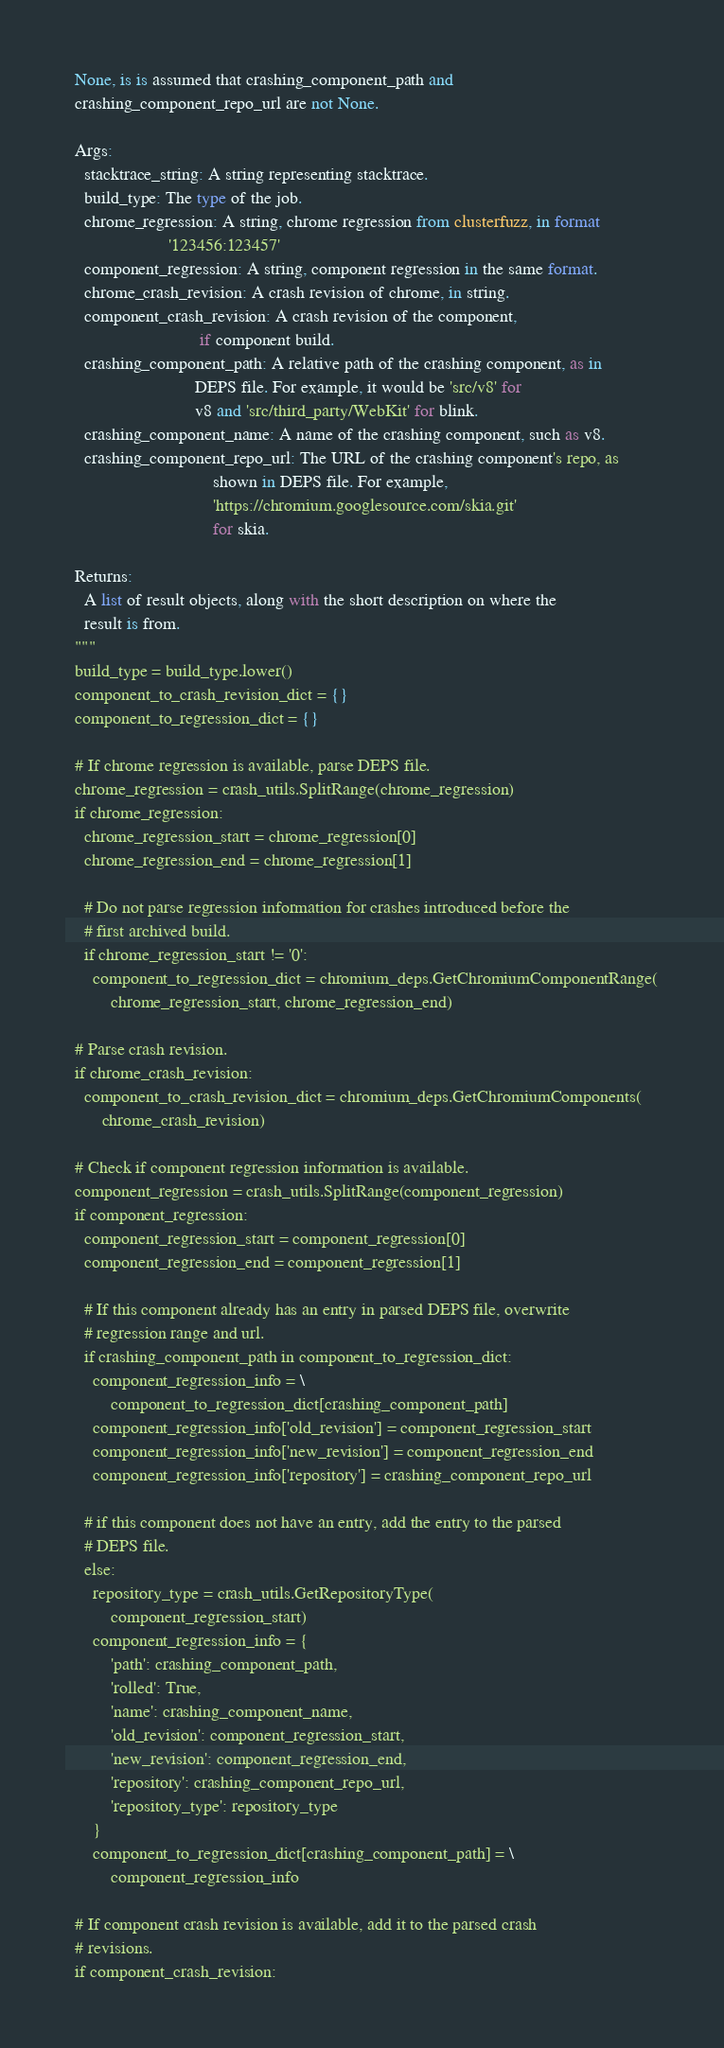<code> <loc_0><loc_0><loc_500><loc_500><_Python_>  None, is is assumed that crashing_component_path and
  crashing_component_repo_url are not None.

  Args:
    stacktrace_string: A string representing stacktrace.
    build_type: The type of the job.
    chrome_regression: A string, chrome regression from clusterfuzz, in format
                       '123456:123457'
    component_regression: A string, component regression in the same format.
    chrome_crash_revision: A crash revision of chrome, in string.
    component_crash_revision: A crash revision of the component,
                              if component build.
    crashing_component_path: A relative path of the crashing component, as in
                             DEPS file. For example, it would be 'src/v8' for
                             v8 and 'src/third_party/WebKit' for blink.
    crashing_component_name: A name of the crashing component, such as v8.
    crashing_component_repo_url: The URL of the crashing component's repo, as
                                 shown in DEPS file. For example,
                                 'https://chromium.googlesource.com/skia.git'
                                 for skia.

  Returns:
    A list of result objects, along with the short description on where the
    result is from.
  """
  build_type = build_type.lower()
  component_to_crash_revision_dict = {}
  component_to_regression_dict = {}

  # If chrome regression is available, parse DEPS file.
  chrome_regression = crash_utils.SplitRange(chrome_regression)
  if chrome_regression:
    chrome_regression_start = chrome_regression[0]
    chrome_regression_end = chrome_regression[1]

    # Do not parse regression information for crashes introduced before the
    # first archived build.
    if chrome_regression_start != '0':
      component_to_regression_dict = chromium_deps.GetChromiumComponentRange(
          chrome_regression_start, chrome_regression_end)

  # Parse crash revision.
  if chrome_crash_revision:
    component_to_crash_revision_dict = chromium_deps.GetChromiumComponents(
        chrome_crash_revision)

  # Check if component regression information is available.
  component_regression = crash_utils.SplitRange(component_regression)
  if component_regression:
    component_regression_start = component_regression[0]
    component_regression_end = component_regression[1]

    # If this component already has an entry in parsed DEPS file, overwrite
    # regression range and url.
    if crashing_component_path in component_to_regression_dict:
      component_regression_info = \
          component_to_regression_dict[crashing_component_path]
      component_regression_info['old_revision'] = component_regression_start
      component_regression_info['new_revision'] = component_regression_end
      component_regression_info['repository'] = crashing_component_repo_url

    # if this component does not have an entry, add the entry to the parsed
    # DEPS file.
    else:
      repository_type = crash_utils.GetRepositoryType(
          component_regression_start)
      component_regression_info = {
          'path': crashing_component_path,
          'rolled': True,
          'name': crashing_component_name,
          'old_revision': component_regression_start,
          'new_revision': component_regression_end,
          'repository': crashing_component_repo_url,
          'repository_type': repository_type
      }
      component_to_regression_dict[crashing_component_path] = \
          component_regression_info

  # If component crash revision is available, add it to the parsed crash
  # revisions.
  if component_crash_revision:
</code> 